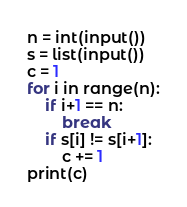<code> <loc_0><loc_0><loc_500><loc_500><_Python_>n = int(input())
s = list(input())
c = 1
for i in range(n):
    if i+1 == n:
        break
    if s[i] != s[i+1]:
        c += 1
print(c)</code> 